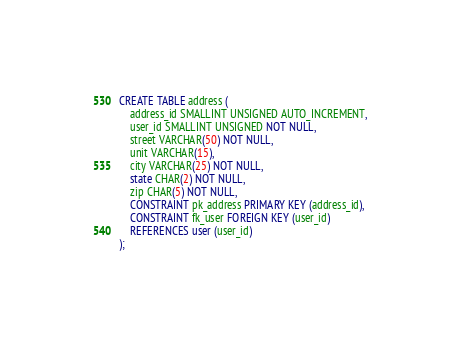Convert code to text. <code><loc_0><loc_0><loc_500><loc_500><_SQL_>CREATE TABLE address (
    address_id SMALLINT UNSIGNED AUTO_INCREMENT,
    user_id SMALLINT UNSIGNED NOT NULL,
    street VARCHAR(50) NOT NULL,
    unit VARCHAR(15),
    city VARCHAR(25) NOT NULL,
    state CHAR(2) NOT NULL,
    zip CHAR(5) NOT NULL,
    CONSTRAINT pk_address PRIMARY KEY (address_id),
    CONSTRAINT fk_user FOREIGN KEY (user_id)
    REFERENCES user (user_id)
);
</code> 